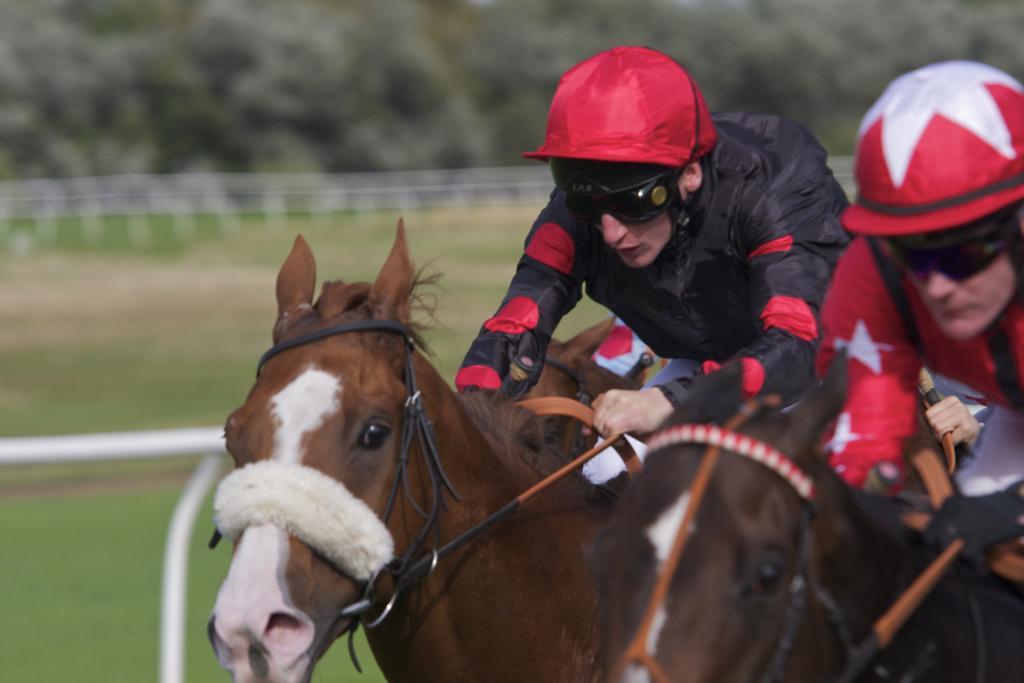Can you describe this image briefly? In this image I can see two persons wearing jackets, caps on their heads and riding the horses. On the left side there is a metal stand. On the ground, I can see the grass. In the background there are many trees. 